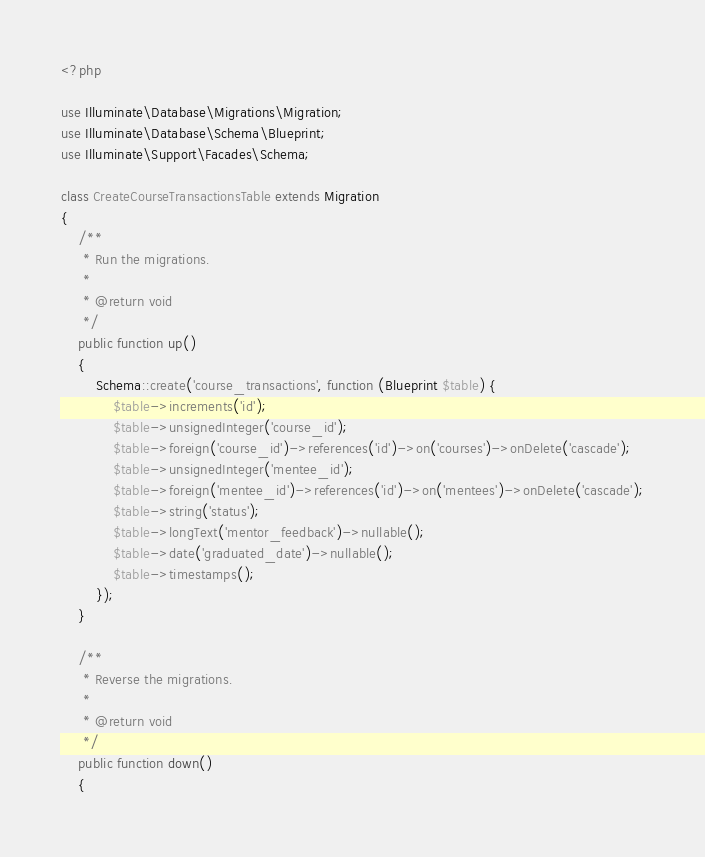Convert code to text. <code><loc_0><loc_0><loc_500><loc_500><_PHP_><?php

use Illuminate\Database\Migrations\Migration;
use Illuminate\Database\Schema\Blueprint;
use Illuminate\Support\Facades\Schema;

class CreateCourseTransactionsTable extends Migration
{
    /**
     * Run the migrations.
     *
     * @return void
     */
    public function up()
    {
        Schema::create('course_transactions', function (Blueprint $table) {
            $table->increments('id');
            $table->unsignedInteger('course_id');
            $table->foreign('course_id')->references('id')->on('courses')->onDelete('cascade');
            $table->unsignedInteger('mentee_id');
            $table->foreign('mentee_id')->references('id')->on('mentees')->onDelete('cascade');
            $table->string('status');
            $table->longText('mentor_feedback')->nullable();
            $table->date('graduated_date')->nullable();
            $table->timestamps();
        });
    }

    /**
     * Reverse the migrations.
     *
     * @return void
     */
    public function down()
    {</code> 